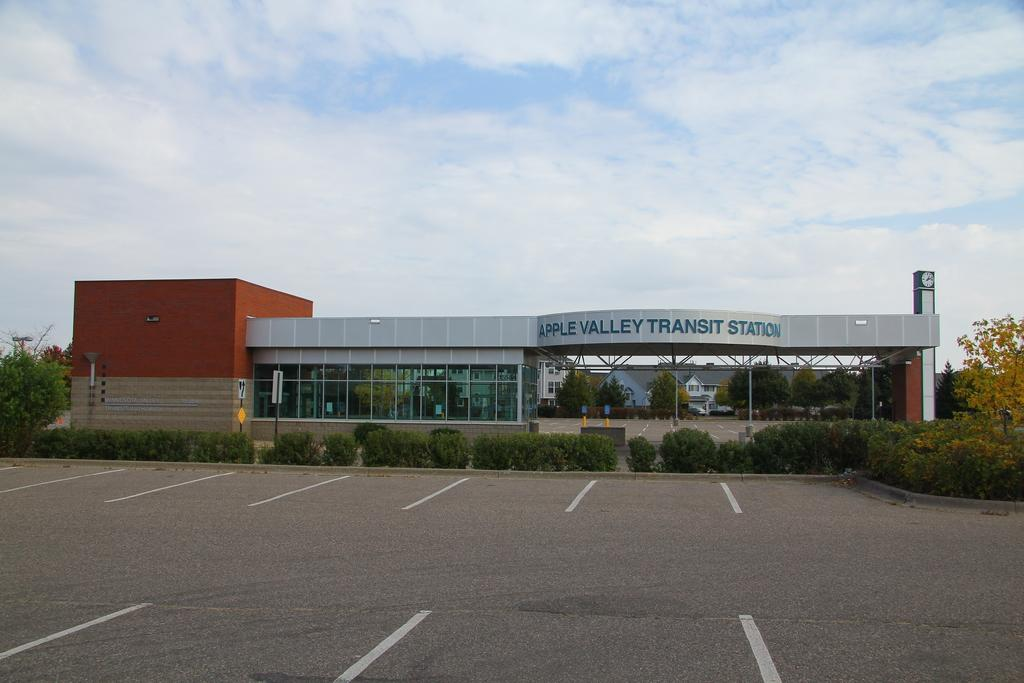What type of structure is present in the image? There is a building in the image. What can be seen growing in the image? There are plants and trees in the image. What can be seen on the road in the image? There are white lines on the road in the image. What type of vegetation is present in the image? There are trees in the image. What else is present on the ground in the image? There are other objects on the ground in the image. What is visible in the background of the image? The sky is visible in the background of the image. What type of lace is draped over the trees in the image? There is no lace present in the image; it features a building, plants, trees, white lines on the road, other objects on the ground, and a visible sky in the background. 